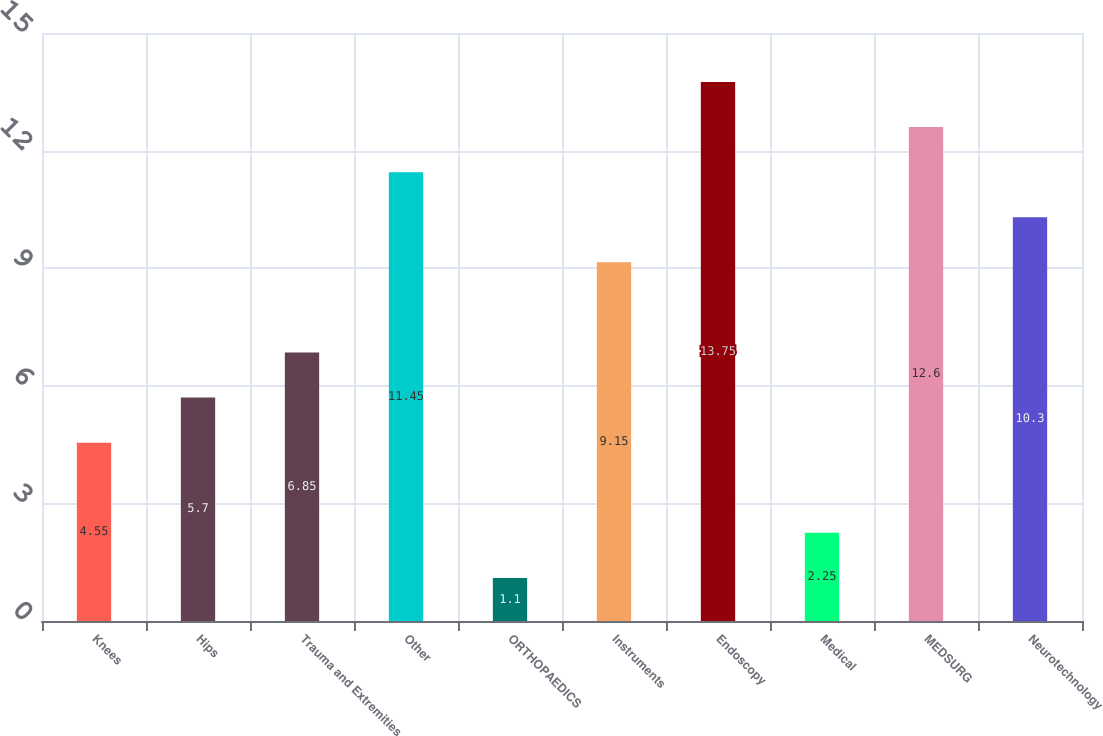<chart> <loc_0><loc_0><loc_500><loc_500><bar_chart><fcel>Knees<fcel>Hips<fcel>Trauma and Extremities<fcel>Other<fcel>ORTHOPAEDICS<fcel>Instruments<fcel>Endoscopy<fcel>Medical<fcel>MEDSURG<fcel>Neurotechnology<nl><fcel>4.55<fcel>5.7<fcel>6.85<fcel>11.45<fcel>1.1<fcel>9.15<fcel>13.75<fcel>2.25<fcel>12.6<fcel>10.3<nl></chart> 